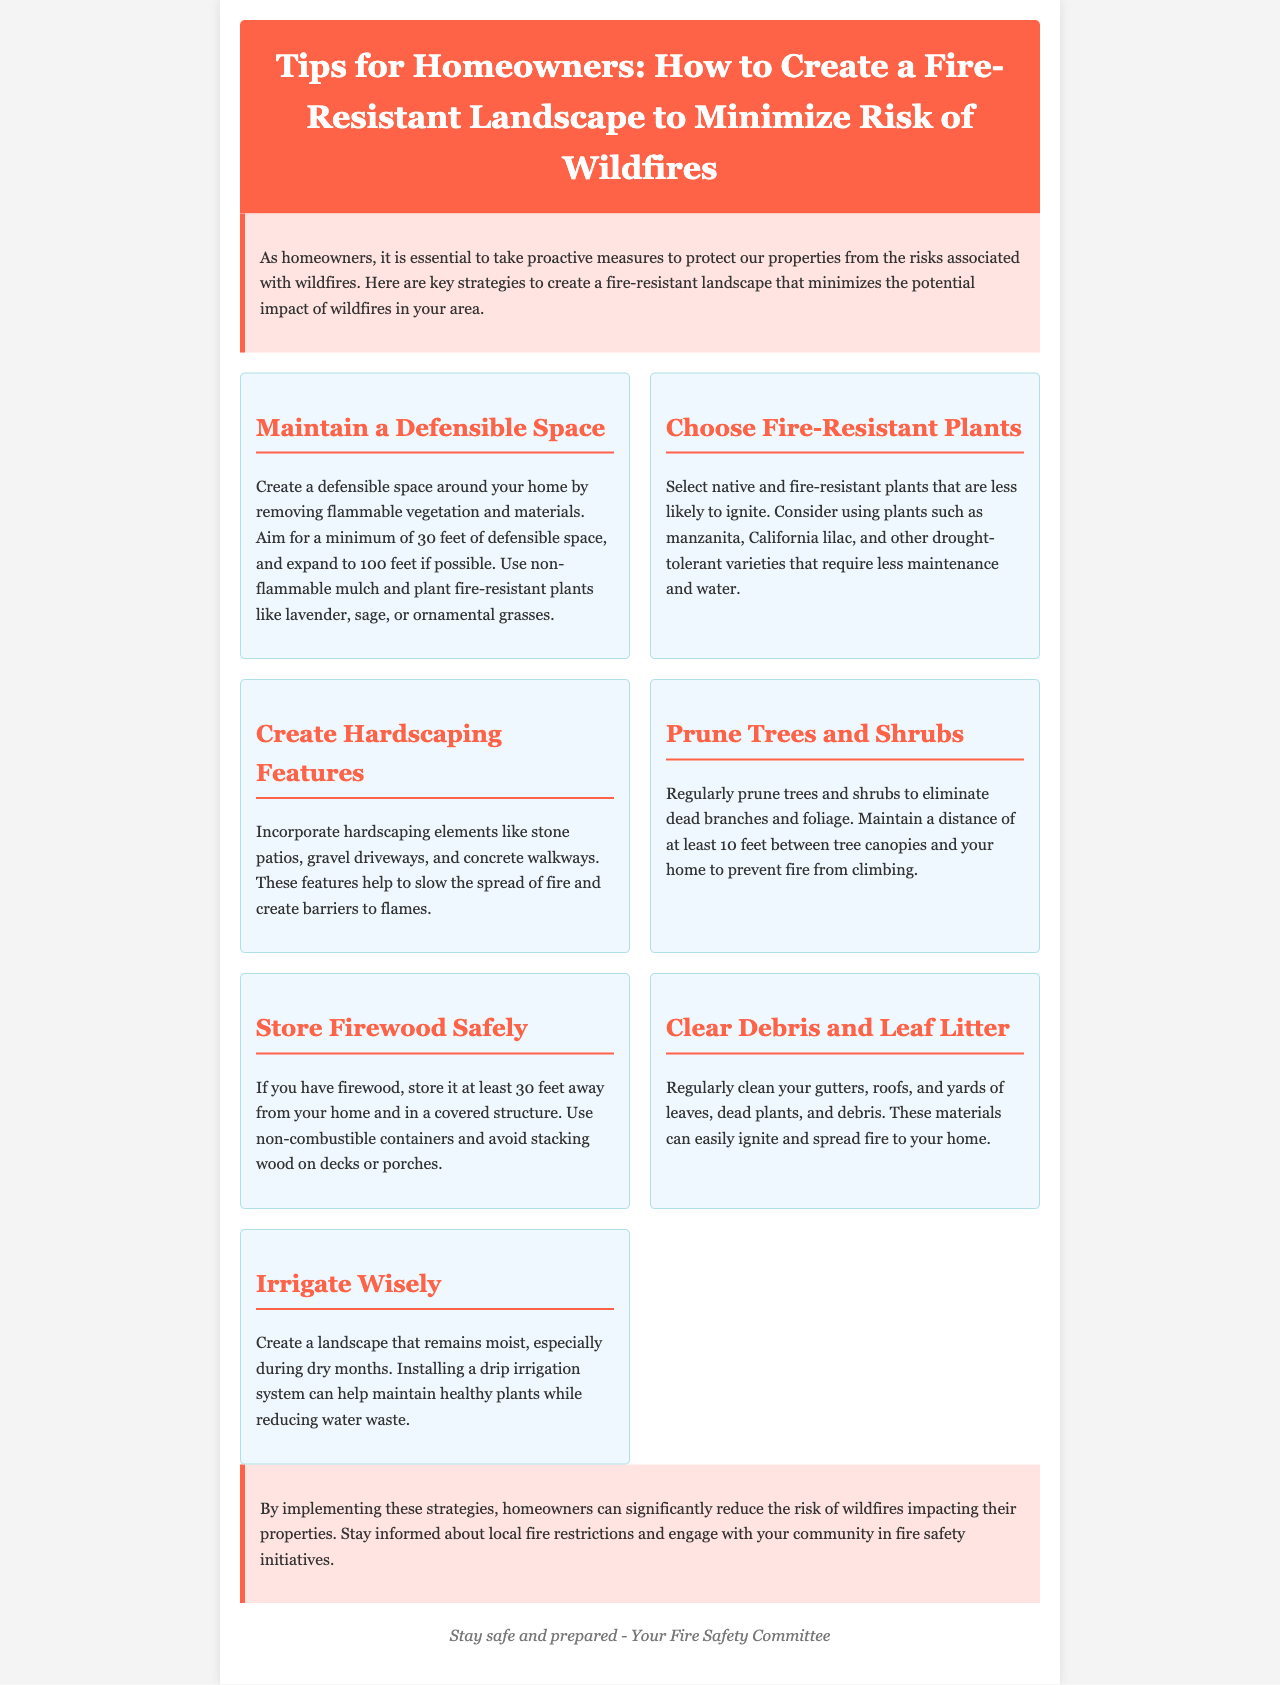What is the minimum defensible space recommended? The document states that homeowners should aim for a minimum of 30 feet of defensible space around their homes.
Answer: 30 feet What plants are suggested for fire-resistant landscaping? The document mentions plants such as lavender, sage, and ornamental grasses as fire-resistant options.
Answer: Lavender, sage, ornamental grasses What is a hardscaping feature mentioned in the newsletter? The newsletter details that stone patios, gravel driveways, and concrete walkways are examples of hardscaping features.
Answer: Stone patios How often should trees and shrubs be pruned? The document emphasizes the importance of regularly pruning trees and shrubs to remove dead branches and foliage.
Answer: Regularly How far should firewood be stored from the home? The recommended distance for storing firewood from the home is at least 30 feet.
Answer: 30 feet What irrigation system is suggested to help maintain moisture? The newsletter recommends installing a drip irrigation system to keep the landscape moist.
Answer: Drip irrigation system What type of materials should be cleared from gutters and roofs? The document indicates that leaves, dead plants, and debris should be regularly cleaned from gutters and roofs.
Answer: Leaves, dead plants, debris What is the main purpose of creating a fire-resistant landscape? The document explains that creating a fire-resistant landscape minimizes the potential impact of wildfires on properties.
Answer: Minimize wildfire impact 